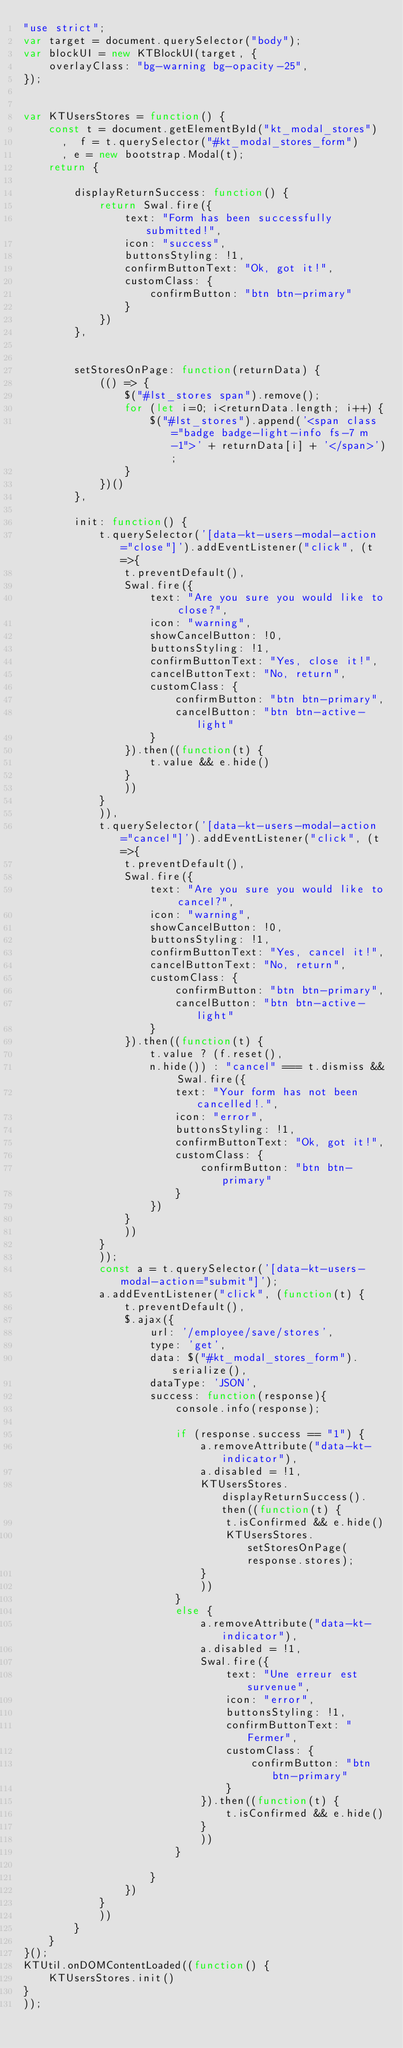<code> <loc_0><loc_0><loc_500><loc_500><_JavaScript_>"use strict";
var target = document.querySelector("body");
var blockUI = new KTBlockUI(target, {
    overlayClass: "bg-warning bg-opacity-25",
});


var KTUsersStores = function() {
    const t = document.getElementById("kt_modal_stores")
      ,  f = t.querySelector("#kt_modal_stores_form")
      , e = new bootstrap.Modal(t);
    return {
        
        displayReturnSuccess: function() {
            return Swal.fire({
                text: "Form has been successfully submitted!",
                icon: "success",
                buttonsStyling: !1,
                confirmButtonText: "Ok, got it!",
                customClass: {
                    confirmButton: "btn btn-primary"
                }
            })
        },

        
        setStoresOnPage: function(returnData) {
            (() => {
                $("#lst_stores span").remove();
                for (let i=0; i<returnData.length; i++) {
                    $("#lst_stores").append('<span class="badge badge-light-info fs-7 m-1">' + returnData[i] + '</span>');
                }
            })()
        },

        init: function() {
            t.querySelector('[data-kt-users-modal-action="close"]').addEventListener("click", (t=>{
                t.preventDefault(),
                Swal.fire({
                    text: "Are you sure you would like to close?",
                    icon: "warning",
                    showCancelButton: !0,
                    buttonsStyling: !1,
                    confirmButtonText: "Yes, close it!",
                    cancelButtonText: "No, return",
                    customClass: {
                        confirmButton: "btn btn-primary",
                        cancelButton: "btn btn-active-light"
                    }
                }).then((function(t) {
                    t.value && e.hide()
                }
                ))
            }
            )),
            t.querySelector('[data-kt-users-modal-action="cancel"]').addEventListener("click", (t=>{
                t.preventDefault(),
                Swal.fire({
                    text: "Are you sure you would like to cancel?",
                    icon: "warning",
                    showCancelButton: !0,
                    buttonsStyling: !1,
                    confirmButtonText: "Yes, cancel it!",
                    cancelButtonText: "No, return",
                    customClass: {
                        confirmButton: "btn btn-primary",
                        cancelButton: "btn btn-active-light"
                    }
                }).then((function(t) {
                    t.value ? (f.reset(),
                    n.hide()) : "cancel" === t.dismiss && Swal.fire({
                        text: "Your form has not been cancelled!.",
                        icon: "error",
                        buttonsStyling: !1,
                        confirmButtonText: "Ok, got it!",
                        customClass: {
                            confirmButton: "btn btn-primary"
                        }
                    })
                }
                ))
            }
            ));
            const a = t.querySelector('[data-kt-users-modal-action="submit"]');
            a.addEventListener("click", (function(t) {
                t.preventDefault(),
                $.ajax({
                    url: '/employee/save/stores',
                    type: 'get',
                    data: $("#kt_modal_stores_form").serialize(),
                    dataType: 'JSON',
                    success: function(response){
                        console.info(response);
                        
                        if (response.success == "1") {
                            a.removeAttribute("data-kt-indicator"),
                            a.disabled = !1,
                            KTUsersStores.displayReturnSuccess().then((function(t) {
                                t.isConfirmed && e.hide()
                                KTUsersStores.setStoresOnPage(response.stores);
                            }
                            ))
                        }
                        else {
                            a.removeAttribute("data-kt-indicator"),
                            a.disabled = !1,
                            Swal.fire({
                                text: "Une erreur est survenue",
                                icon: "error",
                                buttonsStyling: !1,
                                confirmButtonText: "Fermer",
                                customClass: {
                                    confirmButton: "btn btn-primary"
                                }
                            }).then((function(t) {
                                t.isConfirmed && e.hide()
                            }
                            ))
                        }
                        
                    }
                })
            }
            ))
        }
    }
}();
KTUtil.onDOMContentLoaded((function() {
    KTUsersStores.init()
}
));
</code> 